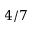<formula> <loc_0><loc_0><loc_500><loc_500>4 / 7</formula> 